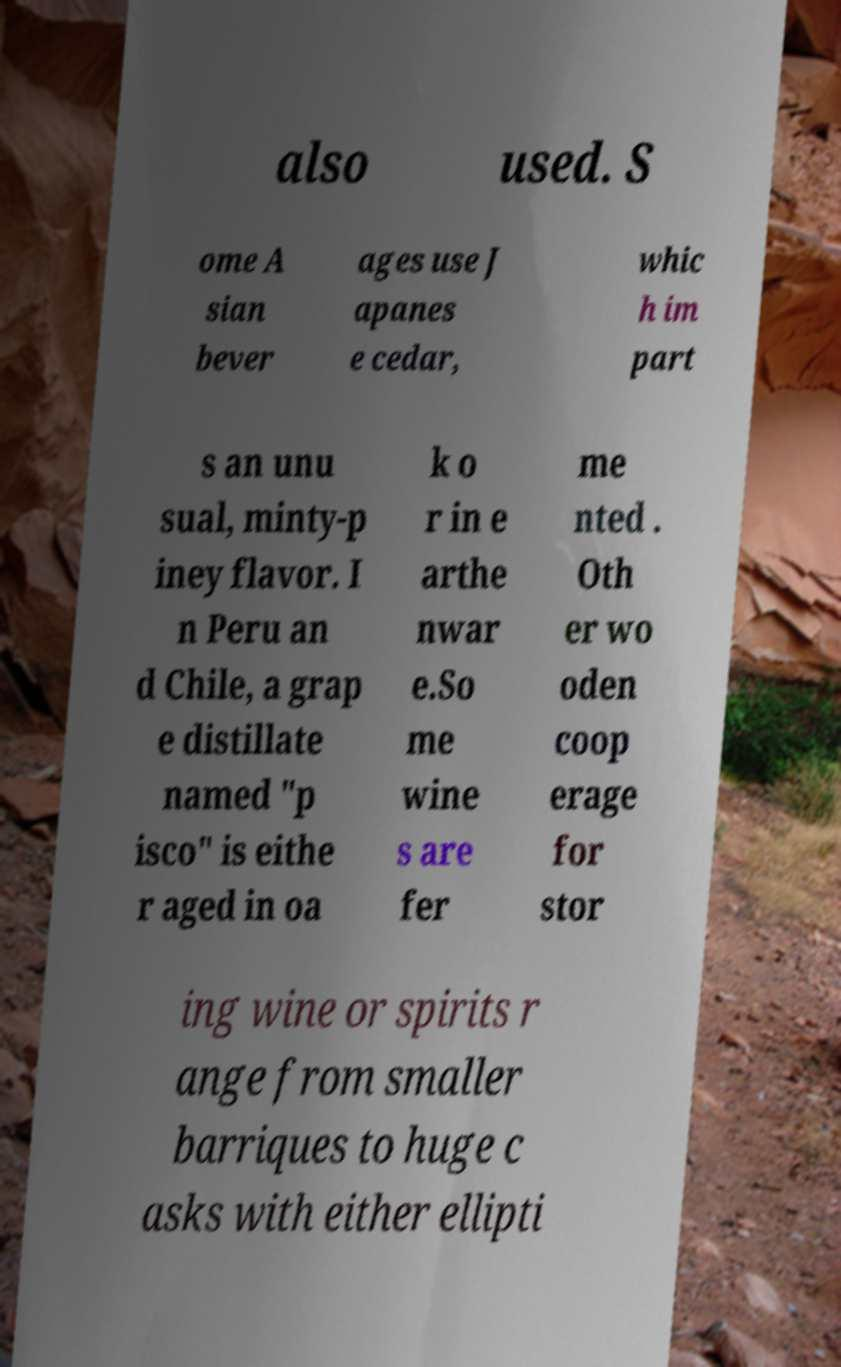Please read and relay the text visible in this image. What does it say? also used. S ome A sian bever ages use J apanes e cedar, whic h im part s an unu sual, minty-p iney flavor. I n Peru an d Chile, a grap e distillate named "p isco" is eithe r aged in oa k o r in e arthe nwar e.So me wine s are fer me nted . Oth er wo oden coop erage for stor ing wine or spirits r ange from smaller barriques to huge c asks with either ellipti 